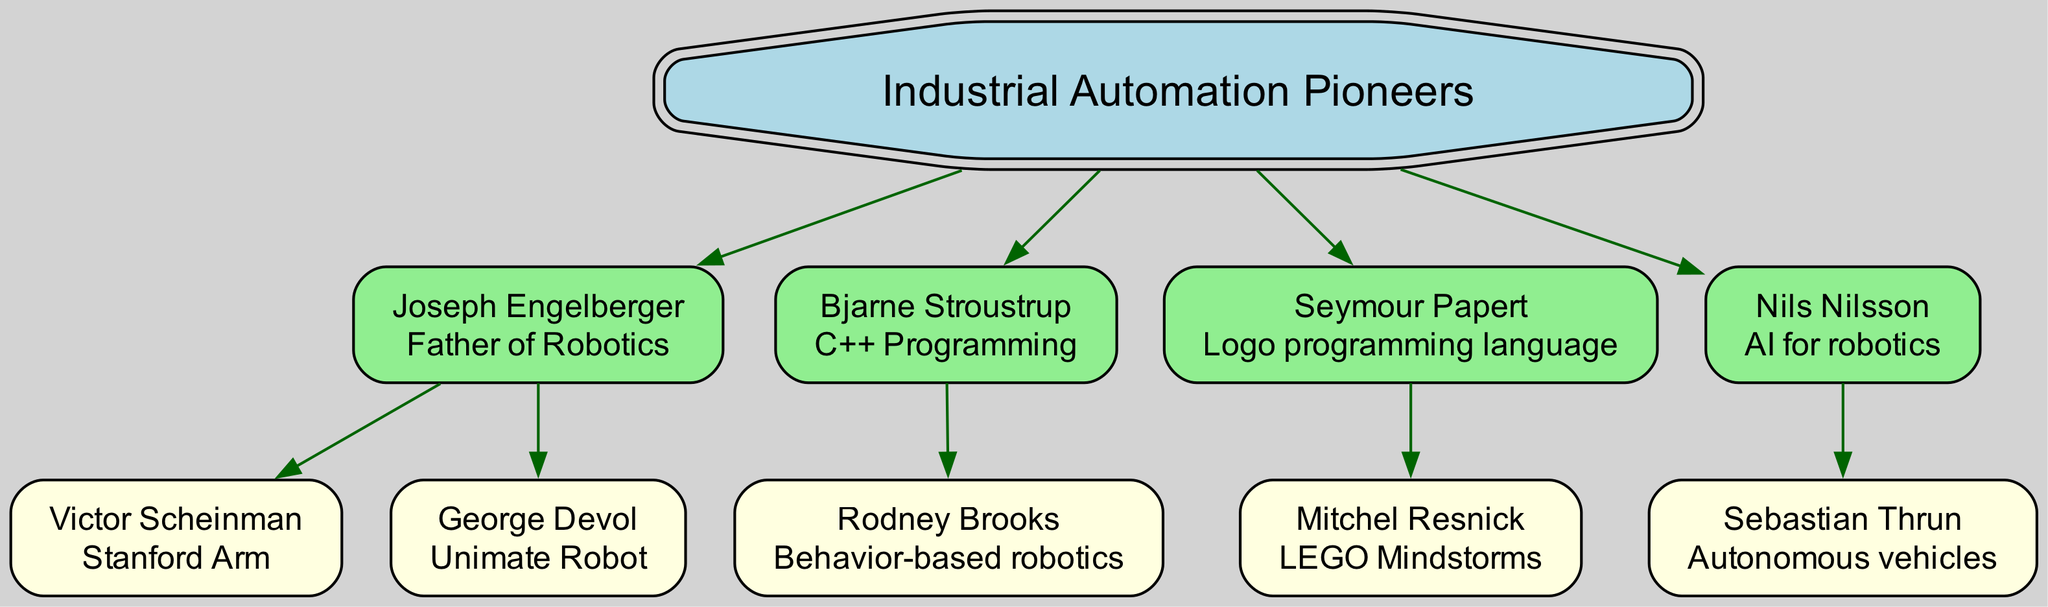What is the highest-level node in the diagram? The diagram's highest-level node is the root node labeled "Industrial Automation Pioneers." This can be identified as the starting point of the family tree.
Answer: Industrial Automation Pioneers Who is credited as the "Father of Robotics"? According to the diagram, Joseph Engelberger is labeled as the "Father of Robotics." This information can be directly read from the contribution listed next to his name.
Answer: Joseph Engelberger How many direct children does Joseph Engelberger have? Joseph Engelberger has two direct children in the diagram: Victor Scheinman and George Devol. This is counted directly from the children nodes connected to him.
Answer: 2 Which researcher is associated with the Unimate Robot? The researcher associated with the Unimate Robot is George Devol, as indicated in the diagram next to his name.
Answer: George Devol What contribution is associated with Bjarne Stroustrup? Bjarne Stroustrup's contribution, as shown in the diagram, is "C++ Programming." This is stated right under his name in the contribution section.
Answer: C++ Programming Who is the child of Seymour Papert? The child of Seymour Papert in the diagram is Mitchel Resnick. This relationship can be observed in the hierarchy where Mitchel Resnick is connected directly beneath Seymour Papert.
Answer: Mitchel Resnick Which research area is attributed to Nils Nilsson? The research area attributed to Nils Nilsson is "AI for robotics," which is presented under his name as his contribution in the diagram.
Answer: AI for robotics What is the unique contribution of Rodney Brooks? Rodney Brooks is credited with "Behavior-based robotics," which is specified next to his name in the diagram.
Answer: Behavior-based robotics How many generations are represented in this family tree? The family tree represents two generations: the root node and its direct children (the first generation), plus their children (the second generation). Therefore, there are a total of two generations in the family tree.
Answer: 2 